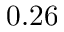Convert formula to latex. <formula><loc_0><loc_0><loc_500><loc_500>0 . 2 6</formula> 